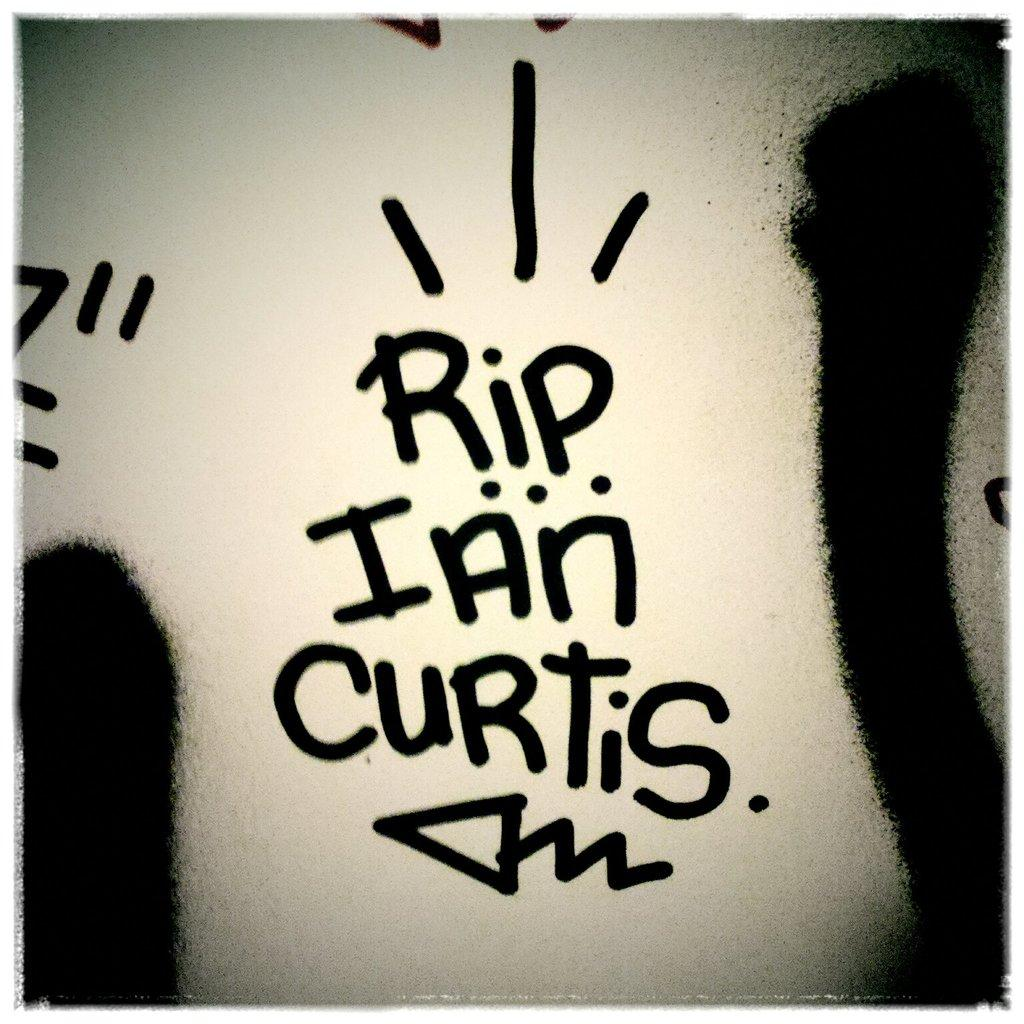Provide a one-sentence caption for the provided image. A text written in marker on white that says "RIP Ian Curtis.". 